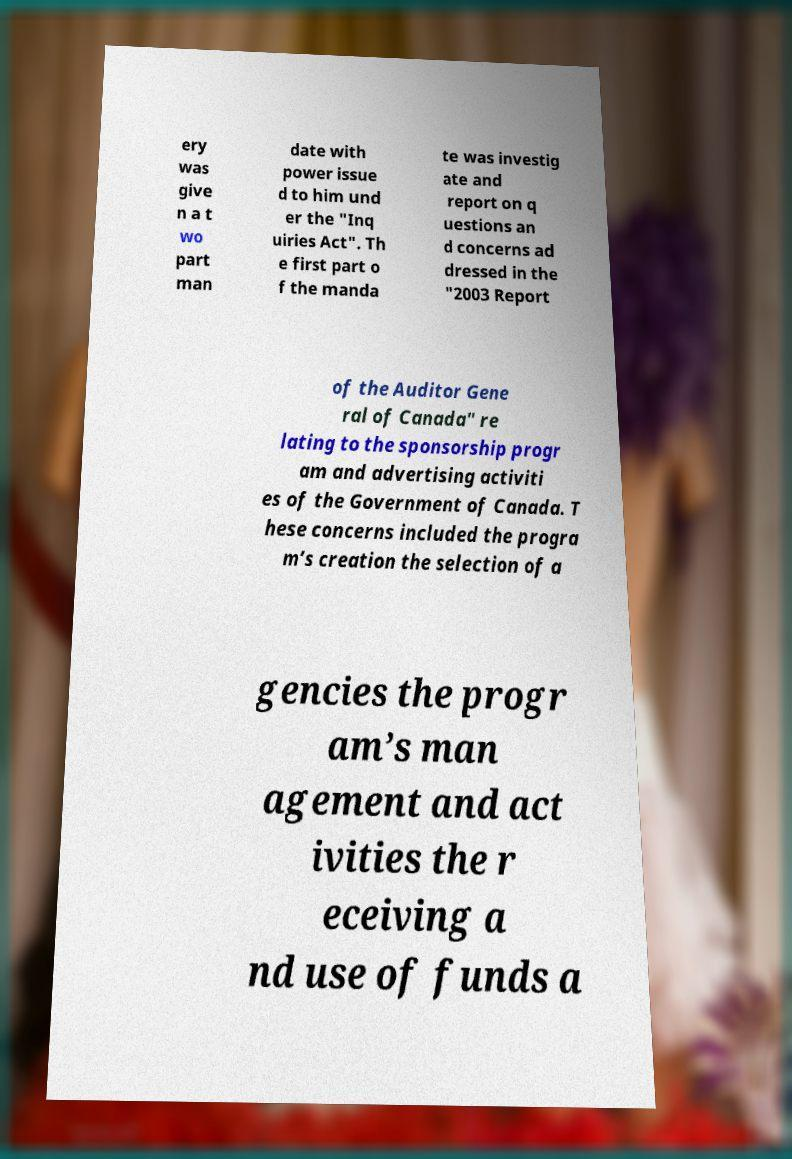Can you accurately transcribe the text from the provided image for me? ery was give n a t wo part man date with power issue d to him und er the "Inq uiries Act". Th e first part o f the manda te was investig ate and report on q uestions an d concerns ad dressed in the "2003 Report of the Auditor Gene ral of Canada" re lating to the sponsorship progr am and advertising activiti es of the Government of Canada. T hese concerns included the progra m’s creation the selection of a gencies the progr am’s man agement and act ivities the r eceiving a nd use of funds a 